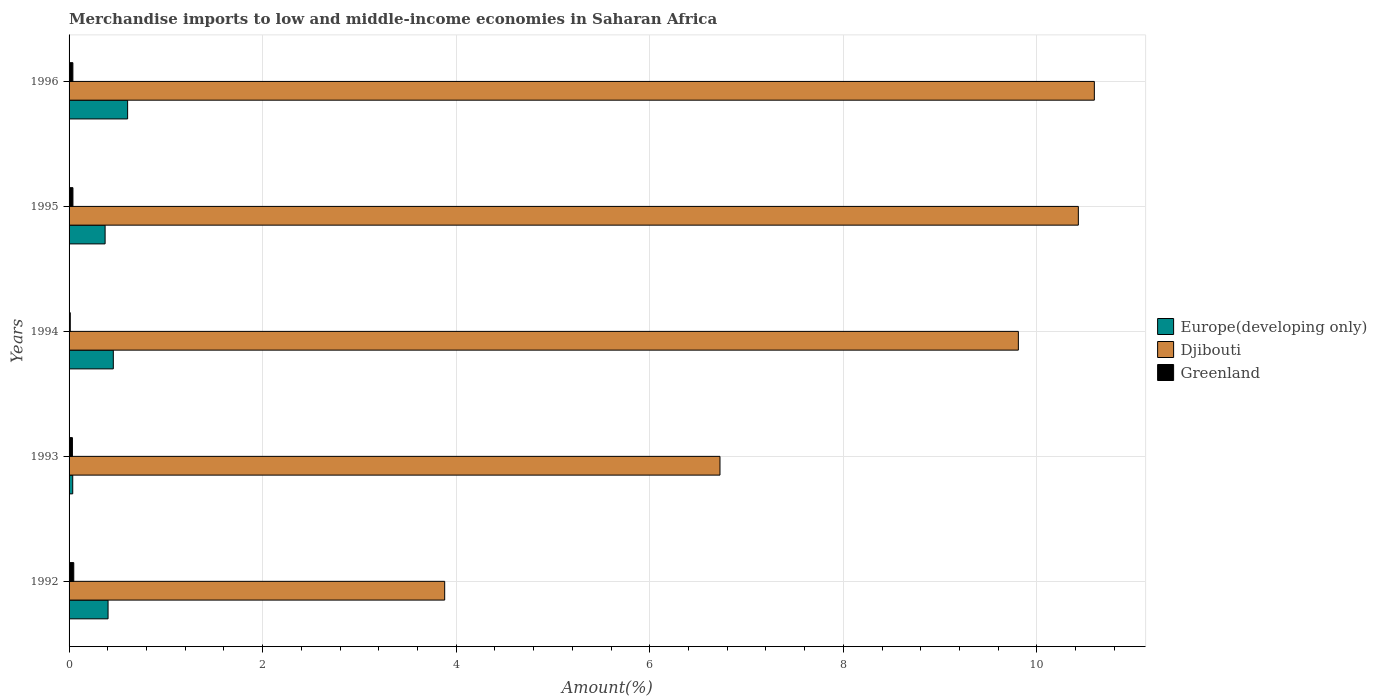How many different coloured bars are there?
Give a very brief answer. 3. Are the number of bars per tick equal to the number of legend labels?
Make the answer very short. Yes. How many bars are there on the 2nd tick from the top?
Ensure brevity in your answer.  3. What is the percentage of amount earned from merchandise imports in Greenland in 1995?
Your answer should be compact. 0.04. Across all years, what is the maximum percentage of amount earned from merchandise imports in Greenland?
Your answer should be compact. 0.05. Across all years, what is the minimum percentage of amount earned from merchandise imports in Greenland?
Make the answer very short. 0.01. In which year was the percentage of amount earned from merchandise imports in Djibouti minimum?
Make the answer very short. 1992. What is the total percentage of amount earned from merchandise imports in Greenland in the graph?
Offer a very short reply. 0.17. What is the difference between the percentage of amount earned from merchandise imports in Europe(developing only) in 1992 and that in 1994?
Provide a succinct answer. -0.05. What is the difference between the percentage of amount earned from merchandise imports in Europe(developing only) in 1992 and the percentage of amount earned from merchandise imports in Greenland in 1993?
Your response must be concise. 0.37. What is the average percentage of amount earned from merchandise imports in Greenland per year?
Make the answer very short. 0.03. In the year 1993, what is the difference between the percentage of amount earned from merchandise imports in Djibouti and percentage of amount earned from merchandise imports in Greenland?
Make the answer very short. 6.69. What is the ratio of the percentage of amount earned from merchandise imports in Djibouti in 1993 to that in 1996?
Your answer should be very brief. 0.63. What is the difference between the highest and the second highest percentage of amount earned from merchandise imports in Europe(developing only)?
Ensure brevity in your answer.  0.15. What is the difference between the highest and the lowest percentage of amount earned from merchandise imports in Djibouti?
Your answer should be compact. 6.71. In how many years, is the percentage of amount earned from merchandise imports in Greenland greater than the average percentage of amount earned from merchandise imports in Greenland taken over all years?
Your response must be concise. 3. Is the sum of the percentage of amount earned from merchandise imports in Europe(developing only) in 1992 and 1994 greater than the maximum percentage of amount earned from merchandise imports in Djibouti across all years?
Give a very brief answer. No. What does the 3rd bar from the top in 1996 represents?
Provide a succinct answer. Europe(developing only). What does the 1st bar from the bottom in 1993 represents?
Offer a terse response. Europe(developing only). Is it the case that in every year, the sum of the percentage of amount earned from merchandise imports in Djibouti and percentage of amount earned from merchandise imports in Greenland is greater than the percentage of amount earned from merchandise imports in Europe(developing only)?
Ensure brevity in your answer.  Yes. How many bars are there?
Make the answer very short. 15. What is the difference between two consecutive major ticks on the X-axis?
Your answer should be compact. 2. Does the graph contain any zero values?
Make the answer very short. No. Does the graph contain grids?
Your answer should be compact. Yes. Where does the legend appear in the graph?
Your response must be concise. Center right. How many legend labels are there?
Provide a short and direct response. 3. How are the legend labels stacked?
Your response must be concise. Vertical. What is the title of the graph?
Your response must be concise. Merchandise imports to low and middle-income economies in Saharan Africa. What is the label or title of the X-axis?
Provide a succinct answer. Amount(%). What is the label or title of the Y-axis?
Your answer should be compact. Years. What is the Amount(%) of Europe(developing only) in 1992?
Provide a succinct answer. 0.4. What is the Amount(%) in Djibouti in 1992?
Give a very brief answer. 3.88. What is the Amount(%) in Greenland in 1992?
Keep it short and to the point. 0.05. What is the Amount(%) of Europe(developing only) in 1993?
Offer a terse response. 0.04. What is the Amount(%) of Djibouti in 1993?
Provide a short and direct response. 6.73. What is the Amount(%) of Greenland in 1993?
Provide a short and direct response. 0.03. What is the Amount(%) in Europe(developing only) in 1994?
Your response must be concise. 0.46. What is the Amount(%) of Djibouti in 1994?
Your answer should be very brief. 9.81. What is the Amount(%) of Greenland in 1994?
Your response must be concise. 0.01. What is the Amount(%) in Europe(developing only) in 1995?
Offer a very short reply. 0.37. What is the Amount(%) in Djibouti in 1995?
Make the answer very short. 10.43. What is the Amount(%) in Greenland in 1995?
Your answer should be very brief. 0.04. What is the Amount(%) of Europe(developing only) in 1996?
Your answer should be very brief. 0.61. What is the Amount(%) in Djibouti in 1996?
Offer a very short reply. 10.59. What is the Amount(%) in Greenland in 1996?
Keep it short and to the point. 0.04. Across all years, what is the maximum Amount(%) of Europe(developing only)?
Ensure brevity in your answer.  0.61. Across all years, what is the maximum Amount(%) in Djibouti?
Give a very brief answer. 10.59. Across all years, what is the maximum Amount(%) of Greenland?
Your answer should be compact. 0.05. Across all years, what is the minimum Amount(%) of Europe(developing only)?
Ensure brevity in your answer.  0.04. Across all years, what is the minimum Amount(%) in Djibouti?
Offer a terse response. 3.88. Across all years, what is the minimum Amount(%) in Greenland?
Your answer should be very brief. 0.01. What is the total Amount(%) of Europe(developing only) in the graph?
Make the answer very short. 1.88. What is the total Amount(%) of Djibouti in the graph?
Ensure brevity in your answer.  41.44. What is the total Amount(%) of Greenland in the graph?
Give a very brief answer. 0.17. What is the difference between the Amount(%) of Europe(developing only) in 1992 and that in 1993?
Your answer should be very brief. 0.36. What is the difference between the Amount(%) in Djibouti in 1992 and that in 1993?
Offer a very short reply. -2.84. What is the difference between the Amount(%) of Greenland in 1992 and that in 1993?
Give a very brief answer. 0.01. What is the difference between the Amount(%) of Europe(developing only) in 1992 and that in 1994?
Your answer should be compact. -0.05. What is the difference between the Amount(%) in Djibouti in 1992 and that in 1994?
Your answer should be compact. -5.93. What is the difference between the Amount(%) in Greenland in 1992 and that in 1994?
Keep it short and to the point. 0.04. What is the difference between the Amount(%) of Europe(developing only) in 1992 and that in 1995?
Provide a succinct answer. 0.03. What is the difference between the Amount(%) of Djibouti in 1992 and that in 1995?
Offer a terse response. -6.55. What is the difference between the Amount(%) of Greenland in 1992 and that in 1995?
Keep it short and to the point. 0.01. What is the difference between the Amount(%) of Europe(developing only) in 1992 and that in 1996?
Keep it short and to the point. -0.2. What is the difference between the Amount(%) in Djibouti in 1992 and that in 1996?
Give a very brief answer. -6.71. What is the difference between the Amount(%) in Greenland in 1992 and that in 1996?
Provide a succinct answer. 0.01. What is the difference between the Amount(%) in Europe(developing only) in 1993 and that in 1994?
Ensure brevity in your answer.  -0.42. What is the difference between the Amount(%) of Djibouti in 1993 and that in 1994?
Give a very brief answer. -3.08. What is the difference between the Amount(%) in Greenland in 1993 and that in 1994?
Offer a terse response. 0.02. What is the difference between the Amount(%) in Europe(developing only) in 1993 and that in 1995?
Offer a very short reply. -0.33. What is the difference between the Amount(%) in Djibouti in 1993 and that in 1995?
Your answer should be compact. -3.7. What is the difference between the Amount(%) in Greenland in 1993 and that in 1995?
Provide a succinct answer. -0.01. What is the difference between the Amount(%) of Europe(developing only) in 1993 and that in 1996?
Offer a very short reply. -0.57. What is the difference between the Amount(%) in Djibouti in 1993 and that in 1996?
Keep it short and to the point. -3.87. What is the difference between the Amount(%) of Greenland in 1993 and that in 1996?
Provide a short and direct response. -0. What is the difference between the Amount(%) of Europe(developing only) in 1994 and that in 1995?
Provide a short and direct response. 0.08. What is the difference between the Amount(%) of Djibouti in 1994 and that in 1995?
Make the answer very short. -0.62. What is the difference between the Amount(%) of Greenland in 1994 and that in 1995?
Ensure brevity in your answer.  -0.03. What is the difference between the Amount(%) in Europe(developing only) in 1994 and that in 1996?
Provide a short and direct response. -0.15. What is the difference between the Amount(%) in Djibouti in 1994 and that in 1996?
Your response must be concise. -0.79. What is the difference between the Amount(%) of Greenland in 1994 and that in 1996?
Your answer should be very brief. -0.03. What is the difference between the Amount(%) of Europe(developing only) in 1995 and that in 1996?
Give a very brief answer. -0.23. What is the difference between the Amount(%) of Djibouti in 1995 and that in 1996?
Offer a terse response. -0.17. What is the difference between the Amount(%) in Greenland in 1995 and that in 1996?
Keep it short and to the point. 0. What is the difference between the Amount(%) in Europe(developing only) in 1992 and the Amount(%) in Djibouti in 1993?
Give a very brief answer. -6.32. What is the difference between the Amount(%) in Europe(developing only) in 1992 and the Amount(%) in Greenland in 1993?
Ensure brevity in your answer.  0.37. What is the difference between the Amount(%) in Djibouti in 1992 and the Amount(%) in Greenland in 1993?
Ensure brevity in your answer.  3.85. What is the difference between the Amount(%) of Europe(developing only) in 1992 and the Amount(%) of Djibouti in 1994?
Ensure brevity in your answer.  -9.41. What is the difference between the Amount(%) of Europe(developing only) in 1992 and the Amount(%) of Greenland in 1994?
Offer a very short reply. 0.39. What is the difference between the Amount(%) of Djibouti in 1992 and the Amount(%) of Greenland in 1994?
Ensure brevity in your answer.  3.87. What is the difference between the Amount(%) of Europe(developing only) in 1992 and the Amount(%) of Djibouti in 1995?
Provide a short and direct response. -10.03. What is the difference between the Amount(%) in Europe(developing only) in 1992 and the Amount(%) in Greenland in 1995?
Ensure brevity in your answer.  0.36. What is the difference between the Amount(%) of Djibouti in 1992 and the Amount(%) of Greenland in 1995?
Provide a short and direct response. 3.84. What is the difference between the Amount(%) of Europe(developing only) in 1992 and the Amount(%) of Djibouti in 1996?
Offer a terse response. -10.19. What is the difference between the Amount(%) in Europe(developing only) in 1992 and the Amount(%) in Greenland in 1996?
Offer a very short reply. 0.36. What is the difference between the Amount(%) of Djibouti in 1992 and the Amount(%) of Greenland in 1996?
Offer a very short reply. 3.84. What is the difference between the Amount(%) in Europe(developing only) in 1993 and the Amount(%) in Djibouti in 1994?
Your answer should be very brief. -9.77. What is the difference between the Amount(%) of Europe(developing only) in 1993 and the Amount(%) of Greenland in 1994?
Your answer should be compact. 0.03. What is the difference between the Amount(%) in Djibouti in 1993 and the Amount(%) in Greenland in 1994?
Your answer should be very brief. 6.71. What is the difference between the Amount(%) of Europe(developing only) in 1993 and the Amount(%) of Djibouti in 1995?
Give a very brief answer. -10.39. What is the difference between the Amount(%) of Europe(developing only) in 1993 and the Amount(%) of Greenland in 1995?
Offer a very short reply. -0. What is the difference between the Amount(%) in Djibouti in 1993 and the Amount(%) in Greenland in 1995?
Your answer should be very brief. 6.69. What is the difference between the Amount(%) of Europe(developing only) in 1993 and the Amount(%) of Djibouti in 1996?
Ensure brevity in your answer.  -10.56. What is the difference between the Amount(%) of Europe(developing only) in 1993 and the Amount(%) of Greenland in 1996?
Keep it short and to the point. -0. What is the difference between the Amount(%) in Djibouti in 1993 and the Amount(%) in Greenland in 1996?
Keep it short and to the point. 6.69. What is the difference between the Amount(%) in Europe(developing only) in 1994 and the Amount(%) in Djibouti in 1995?
Offer a very short reply. -9.97. What is the difference between the Amount(%) in Europe(developing only) in 1994 and the Amount(%) in Greenland in 1995?
Provide a succinct answer. 0.42. What is the difference between the Amount(%) in Djibouti in 1994 and the Amount(%) in Greenland in 1995?
Ensure brevity in your answer.  9.77. What is the difference between the Amount(%) of Europe(developing only) in 1994 and the Amount(%) of Djibouti in 1996?
Make the answer very short. -10.14. What is the difference between the Amount(%) in Europe(developing only) in 1994 and the Amount(%) in Greenland in 1996?
Provide a succinct answer. 0.42. What is the difference between the Amount(%) in Djibouti in 1994 and the Amount(%) in Greenland in 1996?
Your response must be concise. 9.77. What is the difference between the Amount(%) in Europe(developing only) in 1995 and the Amount(%) in Djibouti in 1996?
Offer a very short reply. -10.22. What is the difference between the Amount(%) of Europe(developing only) in 1995 and the Amount(%) of Greenland in 1996?
Keep it short and to the point. 0.33. What is the difference between the Amount(%) of Djibouti in 1995 and the Amount(%) of Greenland in 1996?
Provide a short and direct response. 10.39. What is the average Amount(%) of Europe(developing only) per year?
Give a very brief answer. 0.38. What is the average Amount(%) in Djibouti per year?
Ensure brevity in your answer.  8.29. What is the average Amount(%) of Greenland per year?
Make the answer very short. 0.04. In the year 1992, what is the difference between the Amount(%) of Europe(developing only) and Amount(%) of Djibouti?
Offer a terse response. -3.48. In the year 1992, what is the difference between the Amount(%) in Europe(developing only) and Amount(%) in Greenland?
Your answer should be compact. 0.35. In the year 1992, what is the difference between the Amount(%) in Djibouti and Amount(%) in Greenland?
Provide a succinct answer. 3.83. In the year 1993, what is the difference between the Amount(%) in Europe(developing only) and Amount(%) in Djibouti?
Your response must be concise. -6.69. In the year 1993, what is the difference between the Amount(%) in Europe(developing only) and Amount(%) in Greenland?
Your answer should be very brief. 0. In the year 1993, what is the difference between the Amount(%) of Djibouti and Amount(%) of Greenland?
Give a very brief answer. 6.69. In the year 1994, what is the difference between the Amount(%) of Europe(developing only) and Amount(%) of Djibouti?
Ensure brevity in your answer.  -9.35. In the year 1994, what is the difference between the Amount(%) of Europe(developing only) and Amount(%) of Greenland?
Provide a short and direct response. 0.44. In the year 1994, what is the difference between the Amount(%) of Djibouti and Amount(%) of Greenland?
Offer a terse response. 9.8. In the year 1995, what is the difference between the Amount(%) of Europe(developing only) and Amount(%) of Djibouti?
Offer a terse response. -10.06. In the year 1995, what is the difference between the Amount(%) in Europe(developing only) and Amount(%) in Greenland?
Your answer should be very brief. 0.33. In the year 1995, what is the difference between the Amount(%) of Djibouti and Amount(%) of Greenland?
Offer a very short reply. 10.39. In the year 1996, what is the difference between the Amount(%) in Europe(developing only) and Amount(%) in Djibouti?
Your answer should be very brief. -9.99. In the year 1996, what is the difference between the Amount(%) in Europe(developing only) and Amount(%) in Greenland?
Provide a succinct answer. 0.57. In the year 1996, what is the difference between the Amount(%) in Djibouti and Amount(%) in Greenland?
Your response must be concise. 10.55. What is the ratio of the Amount(%) in Europe(developing only) in 1992 to that in 1993?
Offer a terse response. 10.64. What is the ratio of the Amount(%) of Djibouti in 1992 to that in 1993?
Give a very brief answer. 0.58. What is the ratio of the Amount(%) of Greenland in 1992 to that in 1993?
Give a very brief answer. 1.4. What is the ratio of the Amount(%) of Europe(developing only) in 1992 to that in 1994?
Give a very brief answer. 0.88. What is the ratio of the Amount(%) of Djibouti in 1992 to that in 1994?
Your response must be concise. 0.4. What is the ratio of the Amount(%) in Greenland in 1992 to that in 1994?
Give a very brief answer. 3.96. What is the ratio of the Amount(%) of Europe(developing only) in 1992 to that in 1995?
Offer a very short reply. 1.08. What is the ratio of the Amount(%) of Djibouti in 1992 to that in 1995?
Your answer should be very brief. 0.37. What is the ratio of the Amount(%) of Greenland in 1992 to that in 1995?
Ensure brevity in your answer.  1.21. What is the ratio of the Amount(%) in Europe(developing only) in 1992 to that in 1996?
Keep it short and to the point. 0.67. What is the ratio of the Amount(%) of Djibouti in 1992 to that in 1996?
Provide a short and direct response. 0.37. What is the ratio of the Amount(%) of Greenland in 1992 to that in 1996?
Make the answer very short. 1.23. What is the ratio of the Amount(%) in Europe(developing only) in 1993 to that in 1994?
Offer a terse response. 0.08. What is the ratio of the Amount(%) of Djibouti in 1993 to that in 1994?
Your response must be concise. 0.69. What is the ratio of the Amount(%) of Greenland in 1993 to that in 1994?
Offer a very short reply. 2.83. What is the ratio of the Amount(%) of Europe(developing only) in 1993 to that in 1995?
Give a very brief answer. 0.1. What is the ratio of the Amount(%) of Djibouti in 1993 to that in 1995?
Offer a terse response. 0.64. What is the ratio of the Amount(%) of Greenland in 1993 to that in 1995?
Offer a terse response. 0.87. What is the ratio of the Amount(%) of Europe(developing only) in 1993 to that in 1996?
Provide a succinct answer. 0.06. What is the ratio of the Amount(%) in Djibouti in 1993 to that in 1996?
Provide a succinct answer. 0.63. What is the ratio of the Amount(%) in Greenland in 1993 to that in 1996?
Your answer should be compact. 0.88. What is the ratio of the Amount(%) of Europe(developing only) in 1994 to that in 1995?
Keep it short and to the point. 1.23. What is the ratio of the Amount(%) in Djibouti in 1994 to that in 1995?
Provide a short and direct response. 0.94. What is the ratio of the Amount(%) in Greenland in 1994 to that in 1995?
Provide a succinct answer. 0.31. What is the ratio of the Amount(%) of Europe(developing only) in 1994 to that in 1996?
Provide a succinct answer. 0.76. What is the ratio of the Amount(%) of Djibouti in 1994 to that in 1996?
Your answer should be compact. 0.93. What is the ratio of the Amount(%) of Greenland in 1994 to that in 1996?
Make the answer very short. 0.31. What is the ratio of the Amount(%) in Europe(developing only) in 1995 to that in 1996?
Offer a terse response. 0.62. What is the ratio of the Amount(%) of Djibouti in 1995 to that in 1996?
Provide a short and direct response. 0.98. What is the ratio of the Amount(%) of Greenland in 1995 to that in 1996?
Offer a very short reply. 1.02. What is the difference between the highest and the second highest Amount(%) of Europe(developing only)?
Make the answer very short. 0.15. What is the difference between the highest and the second highest Amount(%) of Djibouti?
Offer a terse response. 0.17. What is the difference between the highest and the second highest Amount(%) in Greenland?
Your answer should be compact. 0.01. What is the difference between the highest and the lowest Amount(%) in Europe(developing only)?
Ensure brevity in your answer.  0.57. What is the difference between the highest and the lowest Amount(%) in Djibouti?
Offer a very short reply. 6.71. What is the difference between the highest and the lowest Amount(%) of Greenland?
Give a very brief answer. 0.04. 